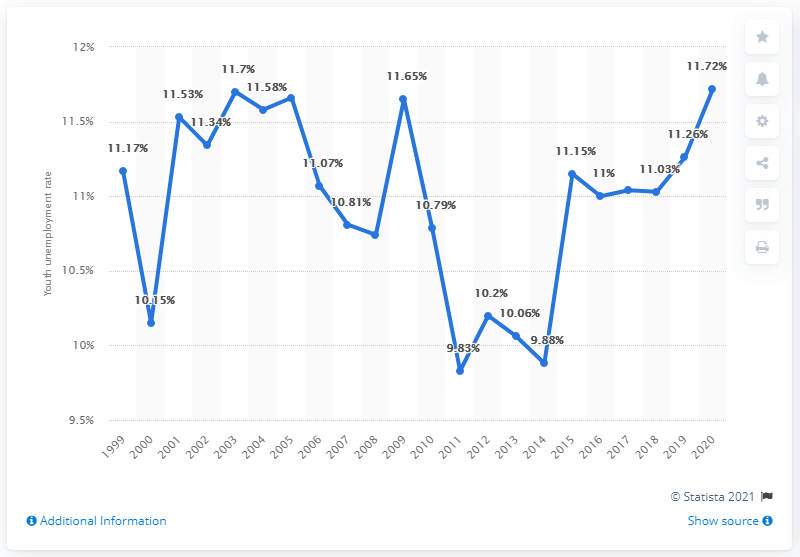Draw attention to some important aspects in this diagram. As of 2020, the youth unemployment rate in Malaysia was 11.72%. 